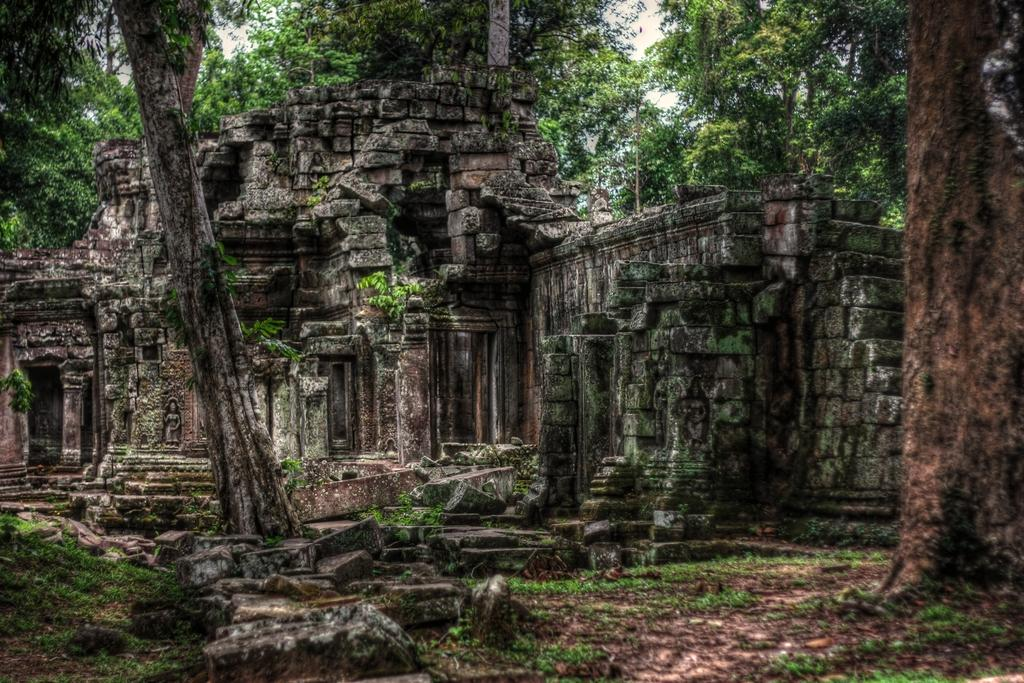What is the main structure in the picture? There is a monument in the picture. What type of vegetation can be seen in the picture? There are trees in the picture. What is the ground covered with in the picture? There is grass on the ground in the picture. How many geese are sitting on the basket in the picture? There are no geese or baskets present in the picture. What type of beds can be seen in the picture? There are no beds present in the picture. 